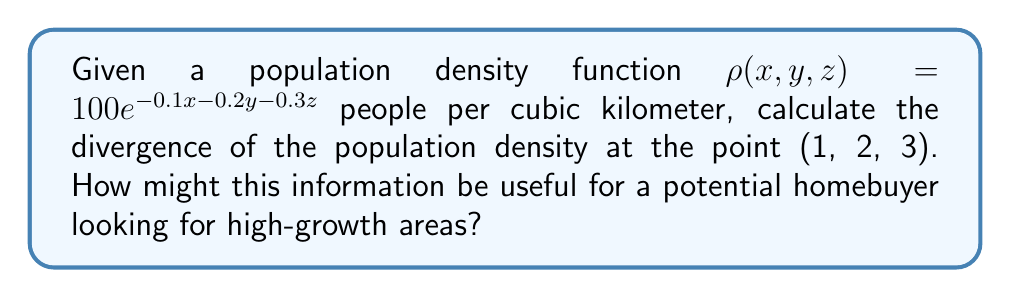Help me with this question. To solve this problem, we need to calculate the divergence of the population density function. The divergence is given by:

$$\nabla \cdot \rho = \frac{\partial \rho}{\partial x} + \frac{\partial \rho}{\partial y} + \frac{\partial \rho}{\partial z}$$

Step 1: Calculate $\frac{\partial \rho}{\partial x}$
$$\frac{\partial \rho}{\partial x} = -0.1 \cdot 100e^{-0.1x - 0.2y - 0.3z} = -10e^{-0.1x - 0.2y - 0.3z}$$

Step 2: Calculate $\frac{\partial \rho}{\partial y}$
$$\frac{\partial \rho}{\partial y} = -0.2 \cdot 100e^{-0.1x - 0.2y - 0.3z} = -20e^{-0.1x - 0.2y - 0.3z}$$

Step 3: Calculate $\frac{\partial \rho}{\partial z}$
$$\frac{\partial \rho}{\partial z} = -0.3 \cdot 100e^{-0.1x - 0.2y - 0.3z} = -30e^{-0.1x - 0.2y - 0.3z}$$

Step 4: Sum the partial derivatives to get the divergence
$$\nabla \cdot \rho = (-10 - 20 - 30)e^{-0.1x - 0.2y - 0.3z} = -60e^{-0.1x - 0.2y - 0.3z}$$

Step 5: Evaluate the divergence at the point (1, 2, 3)
$$\nabla \cdot \rho(1, 2, 3) = -60e^{-0.1(1) - 0.2(2) - 0.3(3)} = -60e^{-1.4} \approx -14.81$$

The negative divergence indicates that the population density is decreasing at this point. For a potential homebuyer, this information suggests that the area around (1, 2, 3) is not experiencing population growth and may not be ideal for investment. Areas with positive divergence would indicate population inflow and potential for future development and appreciation.
Answer: $-60e^{-1.4} \approx -14.81$ people per cubic kilometer per kilometer 